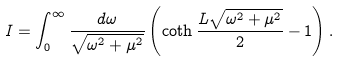<formula> <loc_0><loc_0><loc_500><loc_500>I = \int _ { 0 } ^ { \infty } \frac { d \omega } { \sqrt { \omega ^ { 2 } + \mu ^ { 2 } } } \left ( \coth \frac { L \sqrt { \omega ^ { 2 } + \mu ^ { 2 } } } 2 - 1 \right ) .</formula> 